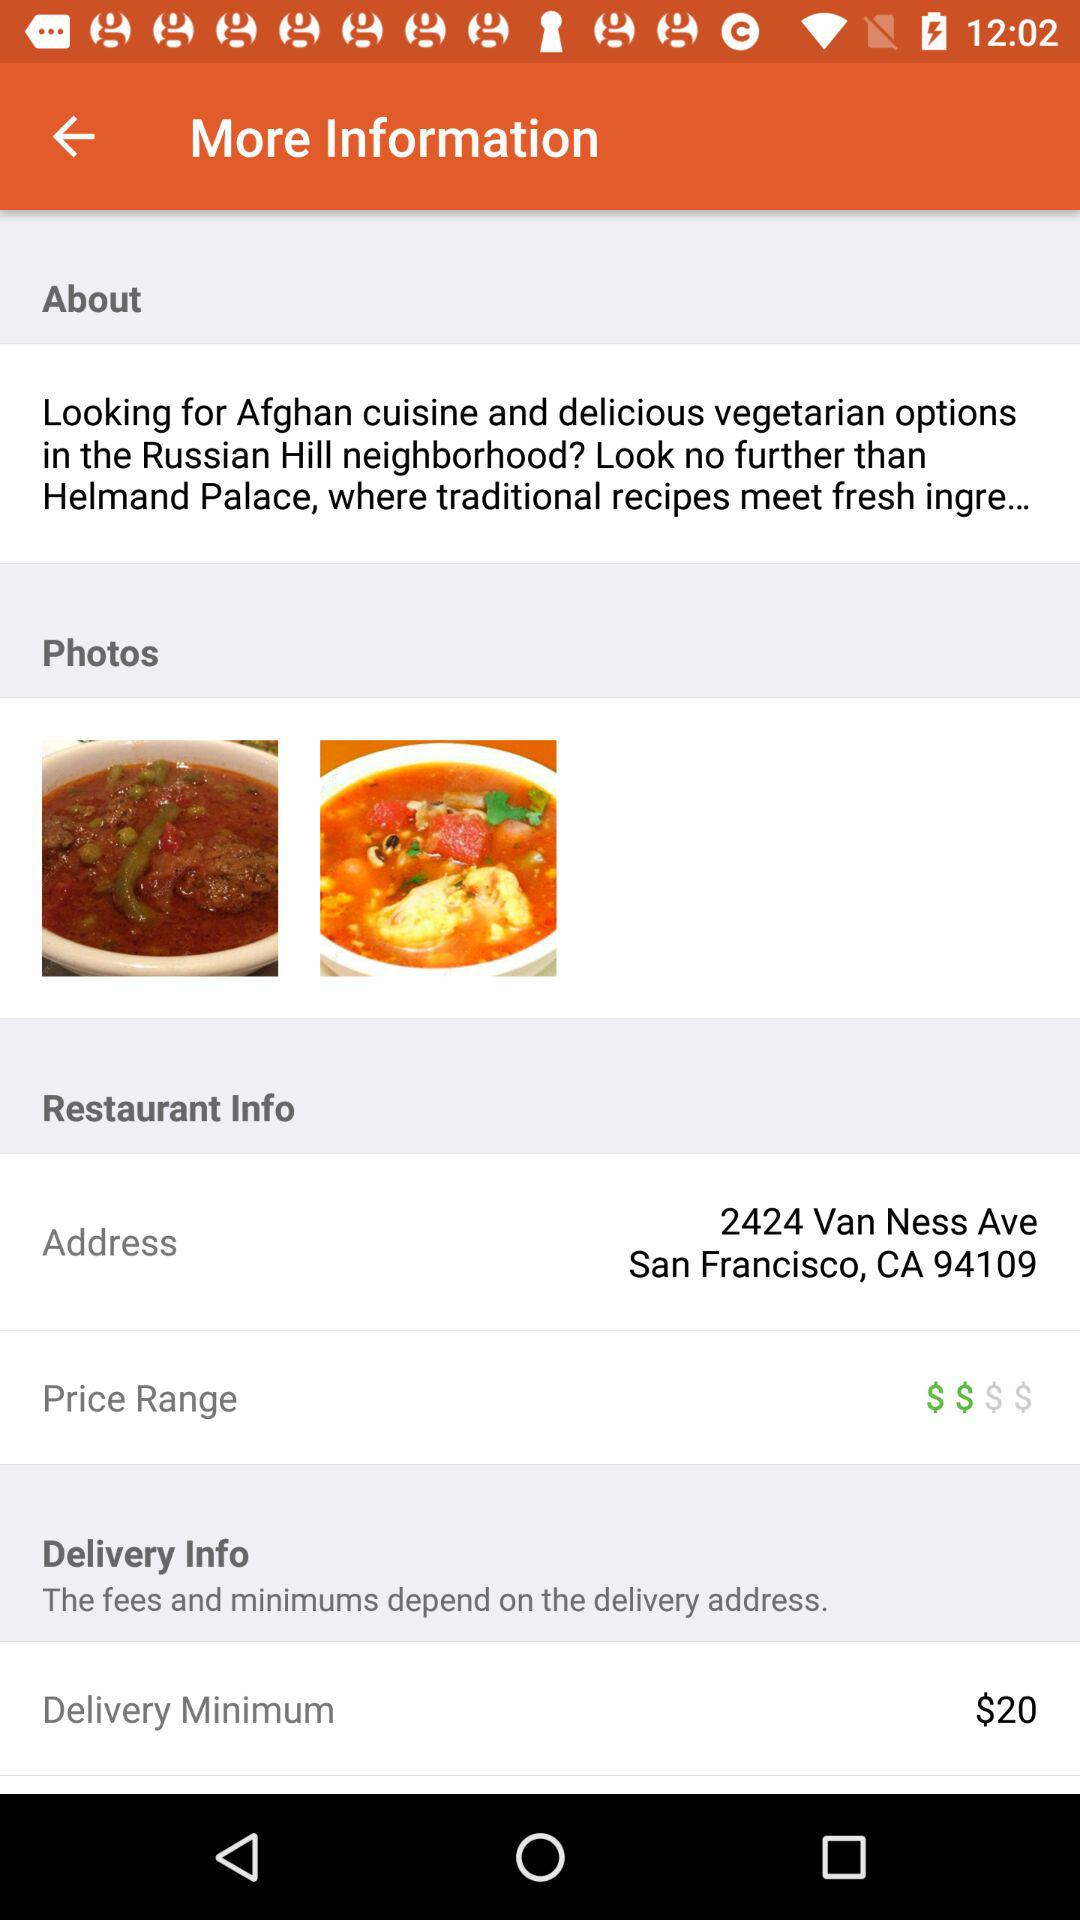What is the address of the restaurant? The address is 2424 Van Ness Ave San Francisco, CA 94109. 